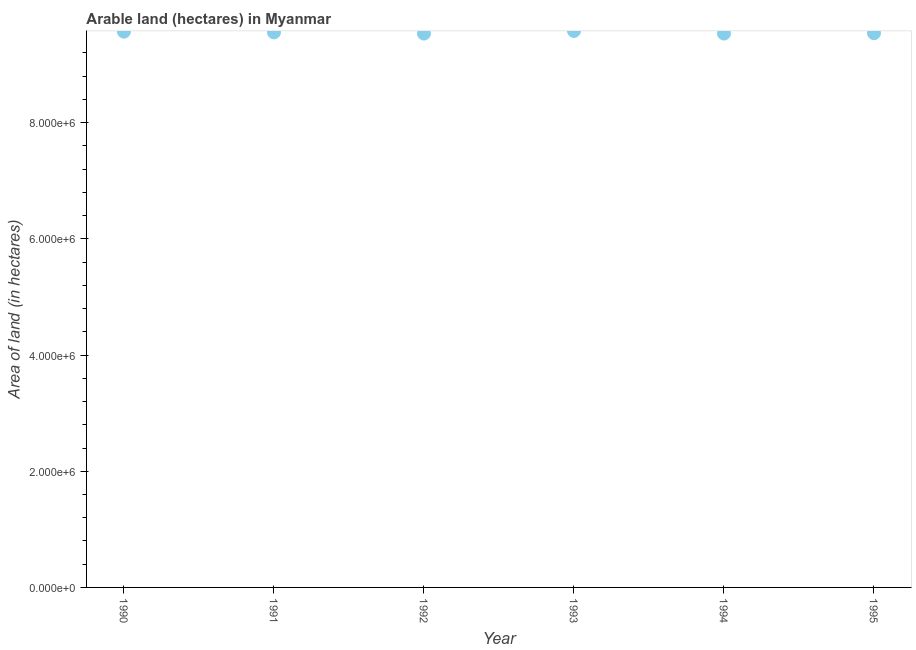What is the area of land in 1995?
Your answer should be compact. 9.54e+06. Across all years, what is the maximum area of land?
Offer a terse response. 9.58e+06. Across all years, what is the minimum area of land?
Provide a short and direct response. 9.53e+06. In which year was the area of land minimum?
Keep it short and to the point. 1992. What is the sum of the area of land?
Make the answer very short. 5.73e+07. What is the difference between the area of land in 1990 and 1991?
Offer a terse response. 1.30e+04. What is the average area of land per year?
Provide a short and direct response. 9.55e+06. What is the median area of land?
Your answer should be very brief. 9.55e+06. What is the ratio of the area of land in 1991 to that in 1994?
Ensure brevity in your answer.  1. Is the area of land in 1990 less than that in 1992?
Ensure brevity in your answer.  No. Is the difference between the area of land in 1990 and 1993 greater than the difference between any two years?
Your response must be concise. No. What is the difference between the highest and the second highest area of land?
Your response must be concise. 1.20e+04. What is the difference between the highest and the lowest area of land?
Provide a succinct answer. 4.50e+04. How many dotlines are there?
Offer a very short reply. 1. How many years are there in the graph?
Your answer should be very brief. 6. What is the difference between two consecutive major ticks on the Y-axis?
Offer a very short reply. 2.00e+06. Does the graph contain any zero values?
Provide a succinct answer. No. What is the title of the graph?
Your answer should be compact. Arable land (hectares) in Myanmar. What is the label or title of the X-axis?
Keep it short and to the point. Year. What is the label or title of the Y-axis?
Ensure brevity in your answer.  Area of land (in hectares). What is the Area of land (in hectares) in 1990?
Make the answer very short. 9.57e+06. What is the Area of land (in hectares) in 1991?
Your answer should be very brief. 9.55e+06. What is the Area of land (in hectares) in 1992?
Keep it short and to the point. 9.53e+06. What is the Area of land (in hectares) in 1993?
Keep it short and to the point. 9.58e+06. What is the Area of land (in hectares) in 1994?
Keep it short and to the point. 9.53e+06. What is the Area of land (in hectares) in 1995?
Give a very brief answer. 9.54e+06. What is the difference between the Area of land (in hectares) in 1990 and 1991?
Offer a very short reply. 1.30e+04. What is the difference between the Area of land (in hectares) in 1990 and 1992?
Give a very brief answer. 3.30e+04. What is the difference between the Area of land (in hectares) in 1990 and 1993?
Offer a very short reply. -1.20e+04. What is the difference between the Area of land (in hectares) in 1990 and 1994?
Your answer should be compact. 3.30e+04. What is the difference between the Area of land (in hectares) in 1990 and 1995?
Your answer should be very brief. 2.70e+04. What is the difference between the Area of land (in hectares) in 1991 and 1992?
Your answer should be compact. 2.00e+04. What is the difference between the Area of land (in hectares) in 1991 and 1993?
Keep it short and to the point. -2.50e+04. What is the difference between the Area of land (in hectares) in 1991 and 1994?
Offer a very short reply. 2.00e+04. What is the difference between the Area of land (in hectares) in 1991 and 1995?
Your answer should be very brief. 1.40e+04. What is the difference between the Area of land (in hectares) in 1992 and 1993?
Your answer should be compact. -4.50e+04. What is the difference between the Area of land (in hectares) in 1992 and 1995?
Keep it short and to the point. -6000. What is the difference between the Area of land (in hectares) in 1993 and 1994?
Offer a terse response. 4.50e+04. What is the difference between the Area of land (in hectares) in 1993 and 1995?
Your answer should be compact. 3.90e+04. What is the difference between the Area of land (in hectares) in 1994 and 1995?
Provide a short and direct response. -6000. What is the ratio of the Area of land (in hectares) in 1990 to that in 1992?
Offer a very short reply. 1. What is the ratio of the Area of land (in hectares) in 1990 to that in 1993?
Give a very brief answer. 1. What is the ratio of the Area of land (in hectares) in 1990 to that in 1994?
Ensure brevity in your answer.  1. What is the ratio of the Area of land (in hectares) in 1991 to that in 1992?
Your response must be concise. 1. What is the ratio of the Area of land (in hectares) in 1991 to that in 1993?
Your response must be concise. 1. What is the ratio of the Area of land (in hectares) in 1991 to that in 1994?
Your answer should be very brief. 1. What is the ratio of the Area of land (in hectares) in 1991 to that in 1995?
Provide a short and direct response. 1. What is the ratio of the Area of land (in hectares) in 1992 to that in 1993?
Your response must be concise. 0.99. What is the ratio of the Area of land (in hectares) in 1992 to that in 1994?
Your answer should be very brief. 1. What is the ratio of the Area of land (in hectares) in 1993 to that in 1994?
Offer a very short reply. 1. What is the ratio of the Area of land (in hectares) in 1993 to that in 1995?
Provide a succinct answer. 1. 